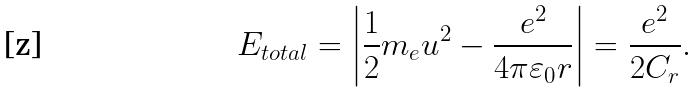<formula> <loc_0><loc_0><loc_500><loc_500>E _ { t o t a l } = \left | \frac { 1 } { 2 } m _ { e } u ^ { 2 } - \frac { e ^ { 2 } } { 4 \pi \varepsilon _ { 0 } r } \right | = \frac { e ^ { 2 } } { 2 C _ { r } } .</formula> 